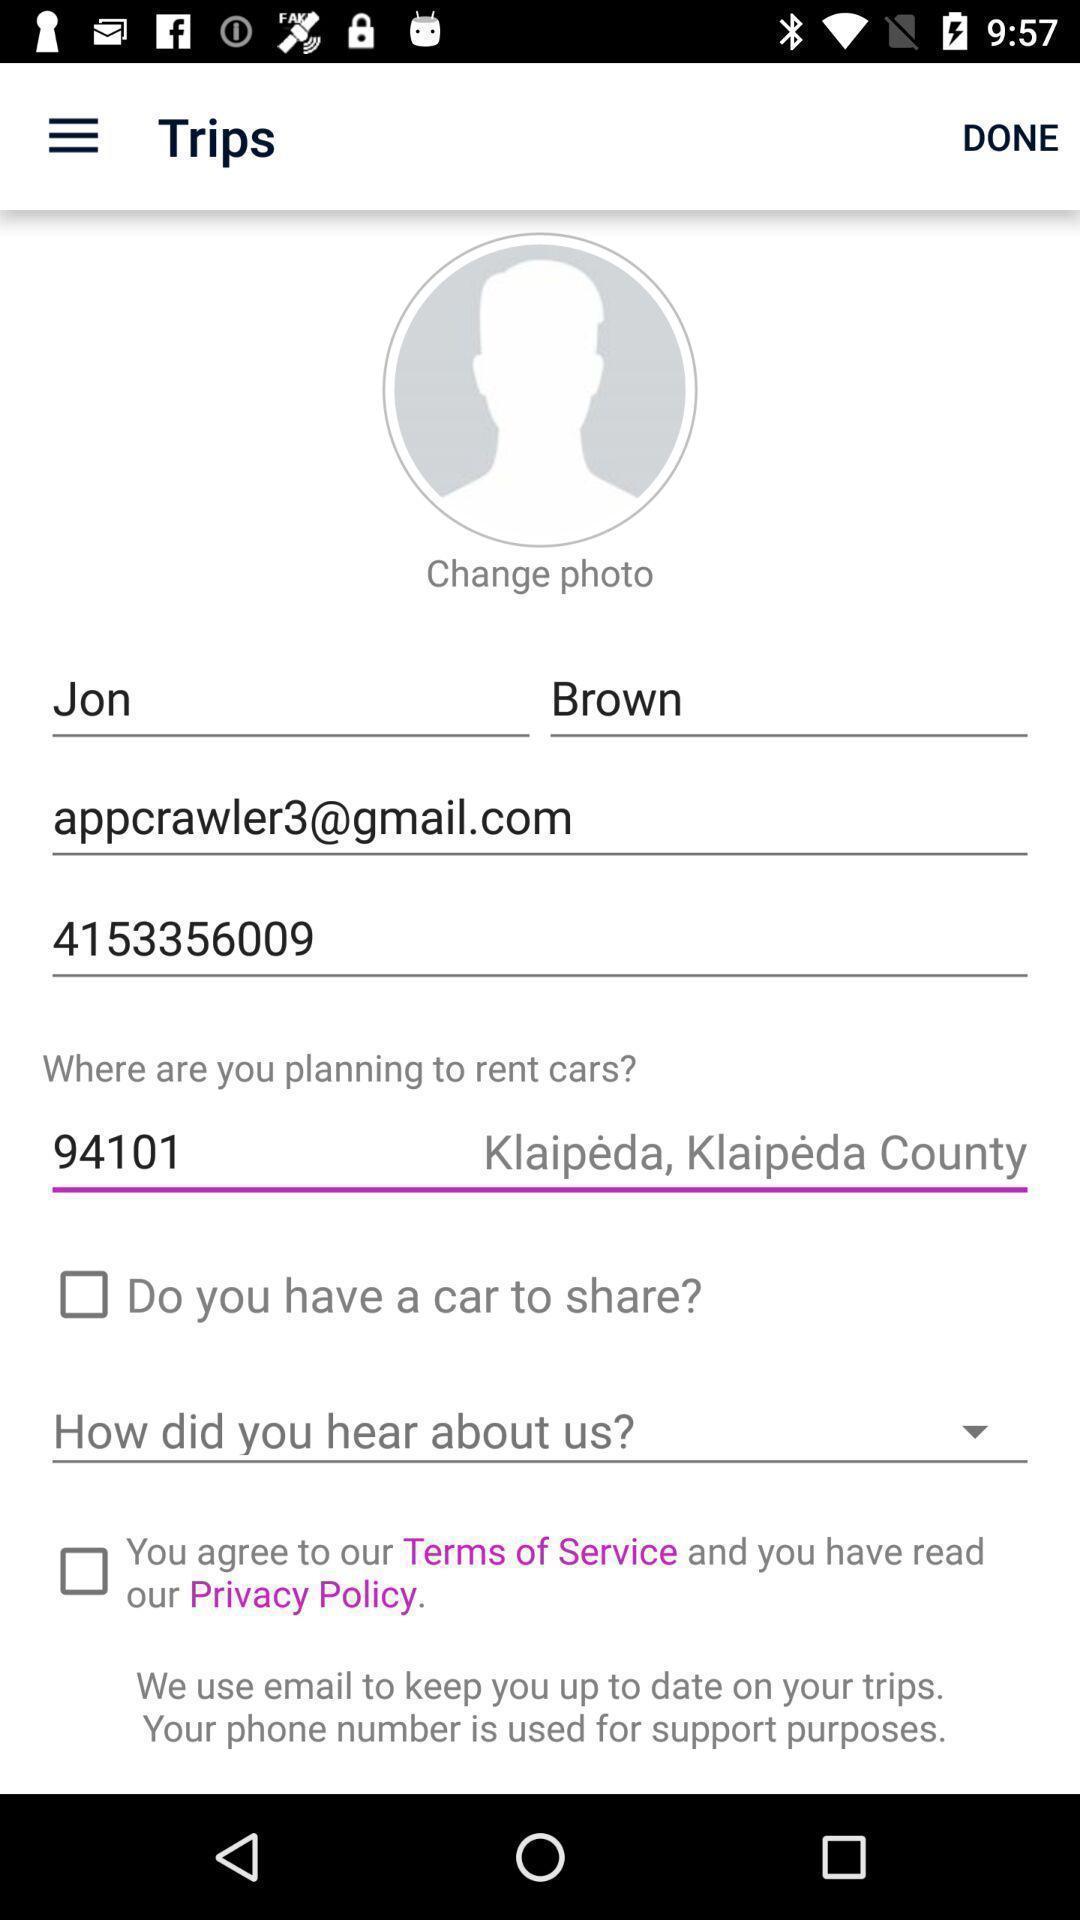Tell me about the visual elements in this screen capture. Screen showing user profile with other fields. 